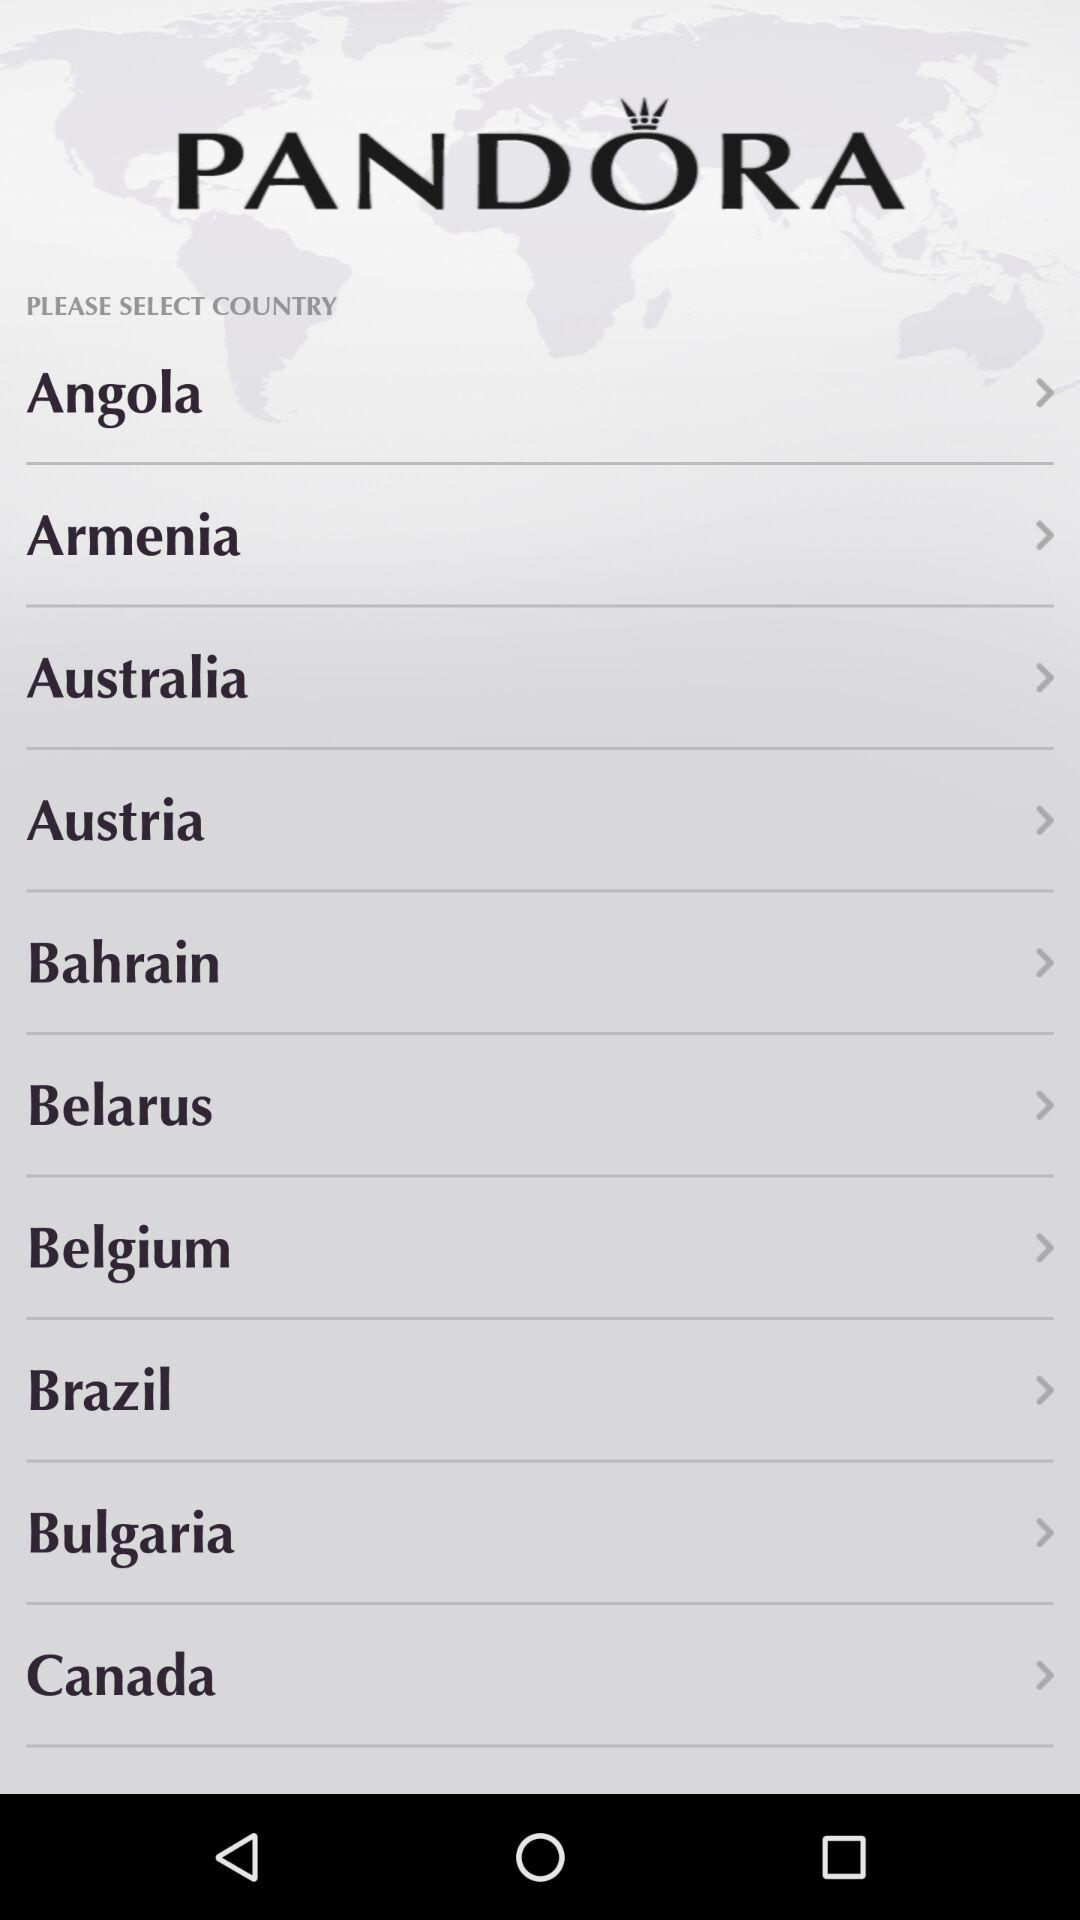What is the application name? The application name is "PANDORA". 